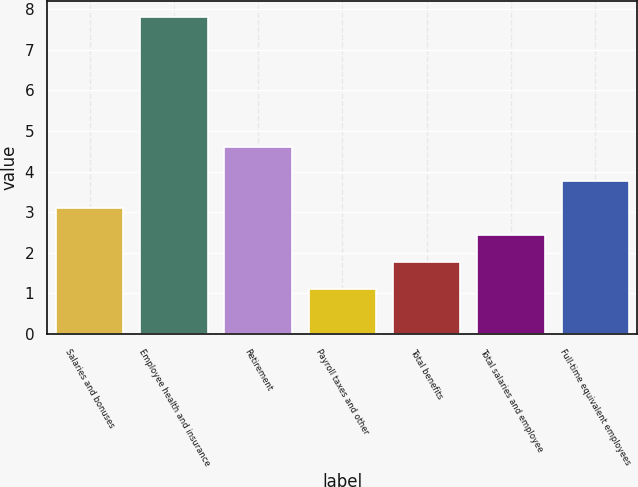Convert chart to OTSL. <chart><loc_0><loc_0><loc_500><loc_500><bar_chart><fcel>Salaries and bonuses<fcel>Employee health and insurance<fcel>Retirement<fcel>Payroll taxes and other<fcel>Total benefits<fcel>Total salaries and employee<fcel>Full-time equivalent employees<nl><fcel>3.11<fcel>7.8<fcel>4.6<fcel>1.1<fcel>1.77<fcel>2.44<fcel>3.78<nl></chart> 